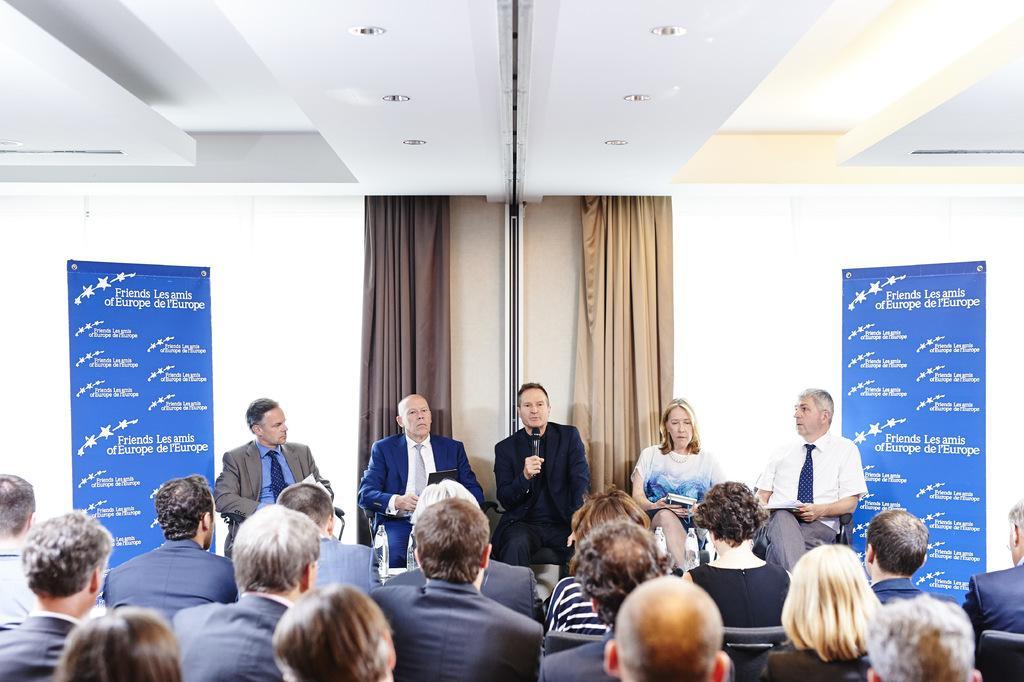In one or two sentences, can you explain what this image depicts? In this images at the bottom few persons are sitting on the chairs and in the background few persons are sitting on the chairs and among them few persons are holding books and a man is holding mic in his hand and we can see hoardings, curtains and lights on the ceiling. 